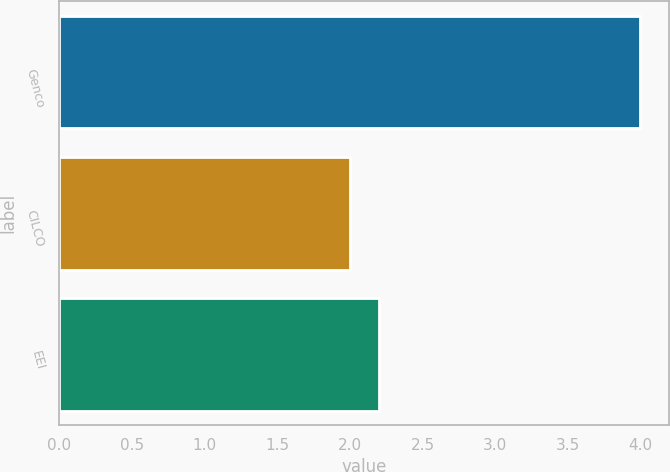Convert chart. <chart><loc_0><loc_0><loc_500><loc_500><bar_chart><fcel>Genco<fcel>CILCO<fcel>EEI<nl><fcel>4<fcel>2<fcel>2.2<nl></chart> 